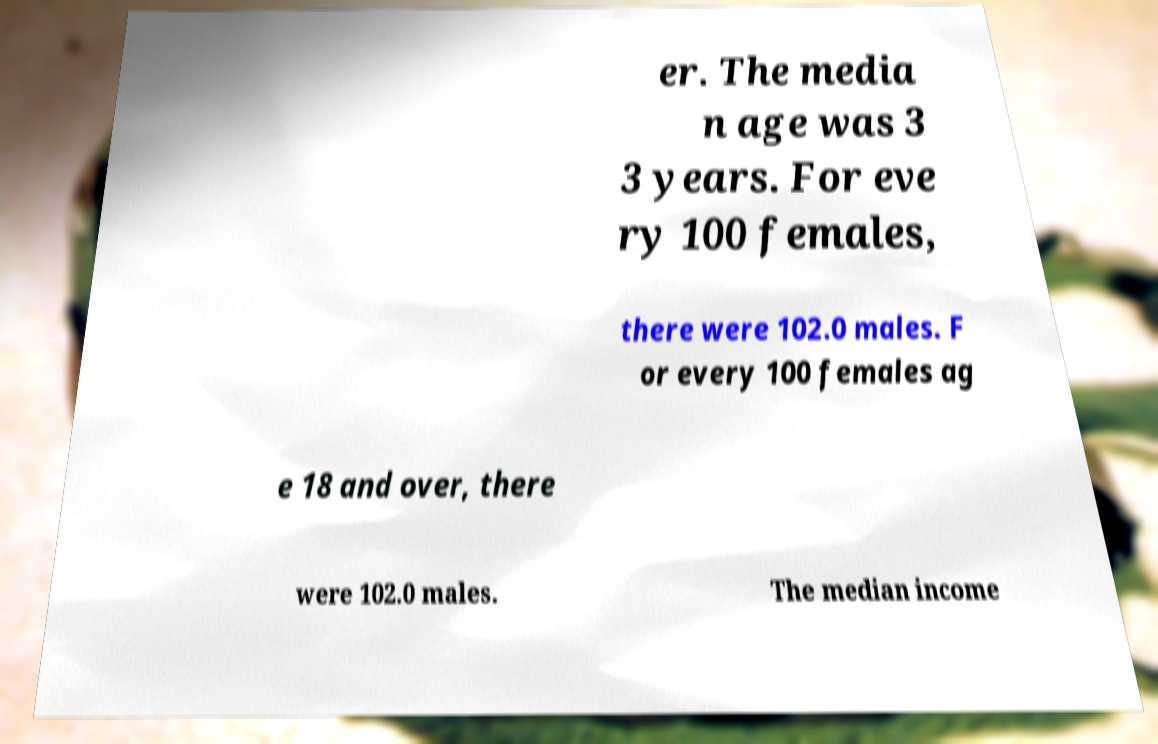Can you accurately transcribe the text from the provided image for me? er. The media n age was 3 3 years. For eve ry 100 females, there were 102.0 males. F or every 100 females ag e 18 and over, there were 102.0 males. The median income 